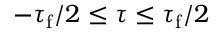<formula> <loc_0><loc_0><loc_500><loc_500>- \tau _ { f } / 2 \leq \tau \leq \tau _ { f } / 2</formula> 